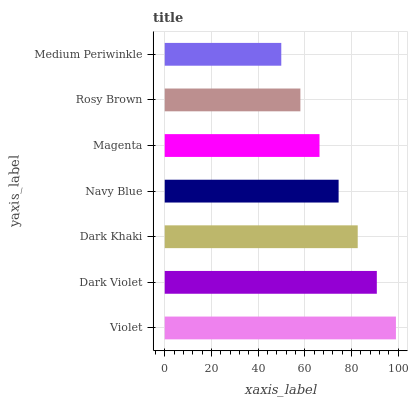Is Medium Periwinkle the minimum?
Answer yes or no. Yes. Is Violet the maximum?
Answer yes or no. Yes. Is Dark Violet the minimum?
Answer yes or no. No. Is Dark Violet the maximum?
Answer yes or no. No. Is Violet greater than Dark Violet?
Answer yes or no. Yes. Is Dark Violet less than Violet?
Answer yes or no. Yes. Is Dark Violet greater than Violet?
Answer yes or no. No. Is Violet less than Dark Violet?
Answer yes or no. No. Is Navy Blue the high median?
Answer yes or no. Yes. Is Navy Blue the low median?
Answer yes or no. Yes. Is Violet the high median?
Answer yes or no. No. Is Dark Khaki the low median?
Answer yes or no. No. 